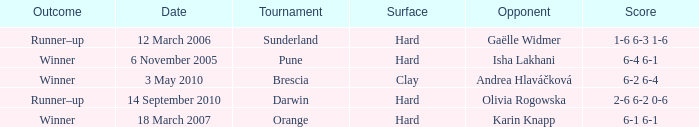What kind of surface was the Tournament at Sunderland played on? Hard. 